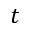Convert formula to latex. <formula><loc_0><loc_0><loc_500><loc_500>t</formula> 